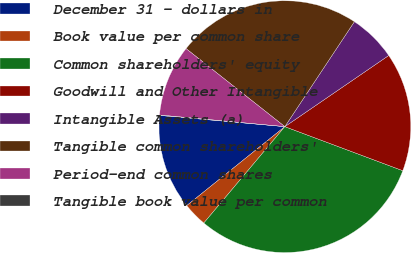Convert chart to OTSL. <chart><loc_0><loc_0><loc_500><loc_500><pie_chart><fcel>December 31 - dollars in<fcel>Book value per common share<fcel>Common shareholders' equity<fcel>Goodwill and Other Intangible<fcel>Intangible Assets (a)<fcel>Tangible common shareholders'<fcel>Period-end common shares<fcel>Tangible book value per common<nl><fcel>12.21%<fcel>3.09%<fcel>30.44%<fcel>15.25%<fcel>6.13%<fcel>23.68%<fcel>9.17%<fcel>0.05%<nl></chart> 